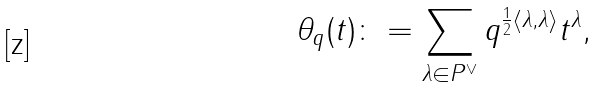Convert formula to latex. <formula><loc_0><loc_0><loc_500><loc_500>\theta _ { q } ( t ) \colon = \sum _ { \lambda \in P ^ { \vee } } q ^ { \frac { 1 } { 2 } \langle \lambda , \lambda \rangle } t ^ { \lambda } ,</formula> 